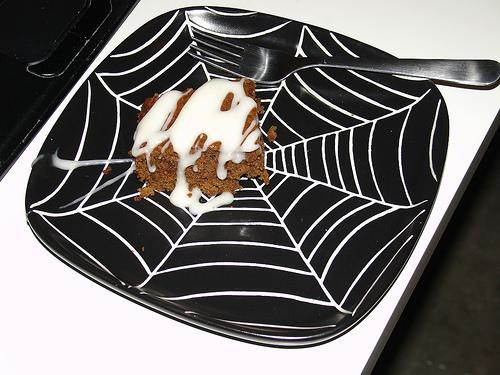What items are near the chocolate dessert on the spider web plate? A silver fork and a white tray are near the chocolate dessert on the spider web plate. Explain the setting of the image in simple words. There is a brown cake with frosting on a fancy plate, and a fork is near it. What type of dessert is on the plate and how is it decorated? A chocolate brownie-like dessert with white drizzling sugary frosting on the plate. Describe the main food item on the plate in detail. A brown chocolate dessert with drizzled white frosting, served on a unique spider web themed plate. Explain the color theme and design of the plate in the image. The plate has a black and white color theme with an interesting spider web pattern. Tell us something about the silverware in the image. There is a clean, silver fork with four prongs placed next to the dessert on the plate. Give a brief overview of the scene in the image. A chocolate dessert with white icing on a black and white spider web design plate, served with a silver fork, and placed on a white tray. In your own words, describe the presentation of the dessert. A delectable chocolate dessert is beautifully presented with white icing on a striking spider web plate. Mention the key elements of the image in a single sentence. The image shows a dessert, a plate with a spider web design, a silver fork, and a white tray. What is the most eye-catching object in the image? A chocolate dessert on a black and white plate with a spider web design. 